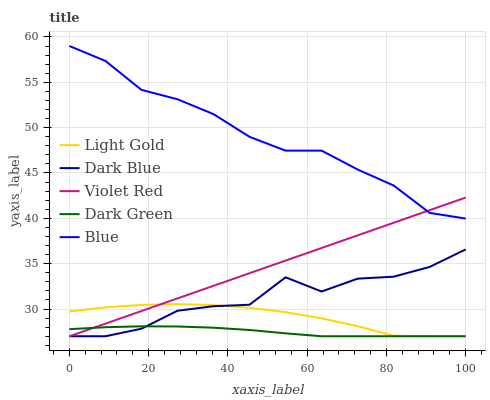Does Dark Green have the minimum area under the curve?
Answer yes or no. Yes. Does Blue have the maximum area under the curve?
Answer yes or no. Yes. Does Dark Blue have the minimum area under the curve?
Answer yes or no. No. Does Dark Blue have the maximum area under the curve?
Answer yes or no. No. Is Violet Red the smoothest?
Answer yes or no. Yes. Is Dark Blue the roughest?
Answer yes or no. Yes. Is Dark Blue the smoothest?
Answer yes or no. No. Is Violet Red the roughest?
Answer yes or no. No. Does Dark Blue have the lowest value?
Answer yes or no. Yes. Does Blue have the highest value?
Answer yes or no. Yes. Does Dark Blue have the highest value?
Answer yes or no. No. Is Light Gold less than Blue?
Answer yes or no. Yes. Is Blue greater than Light Gold?
Answer yes or no. Yes. Does Light Gold intersect Dark Blue?
Answer yes or no. Yes. Is Light Gold less than Dark Blue?
Answer yes or no. No. Is Light Gold greater than Dark Blue?
Answer yes or no. No. Does Light Gold intersect Blue?
Answer yes or no. No. 